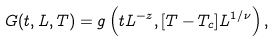Convert formula to latex. <formula><loc_0><loc_0><loc_500><loc_500>G ( t , L , T ) = g \left ( t L ^ { - z } , [ T - T _ { c } ] L ^ { 1 / \nu } \right ) ,</formula> 